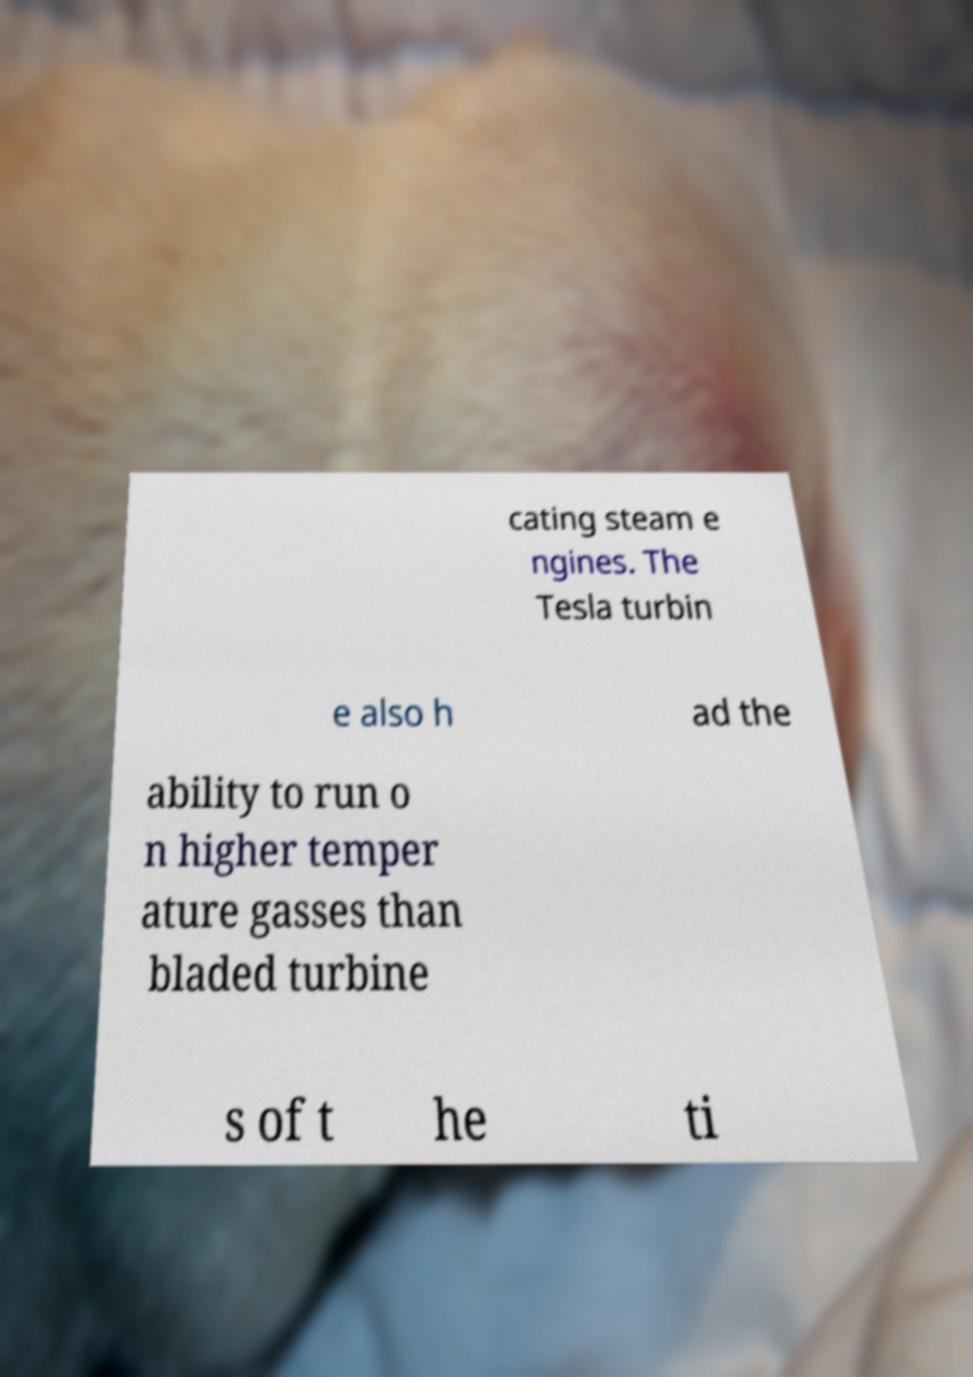Could you assist in decoding the text presented in this image and type it out clearly? cating steam e ngines. The Tesla turbin e also h ad the ability to run o n higher temper ature gasses than bladed turbine s of t he ti 